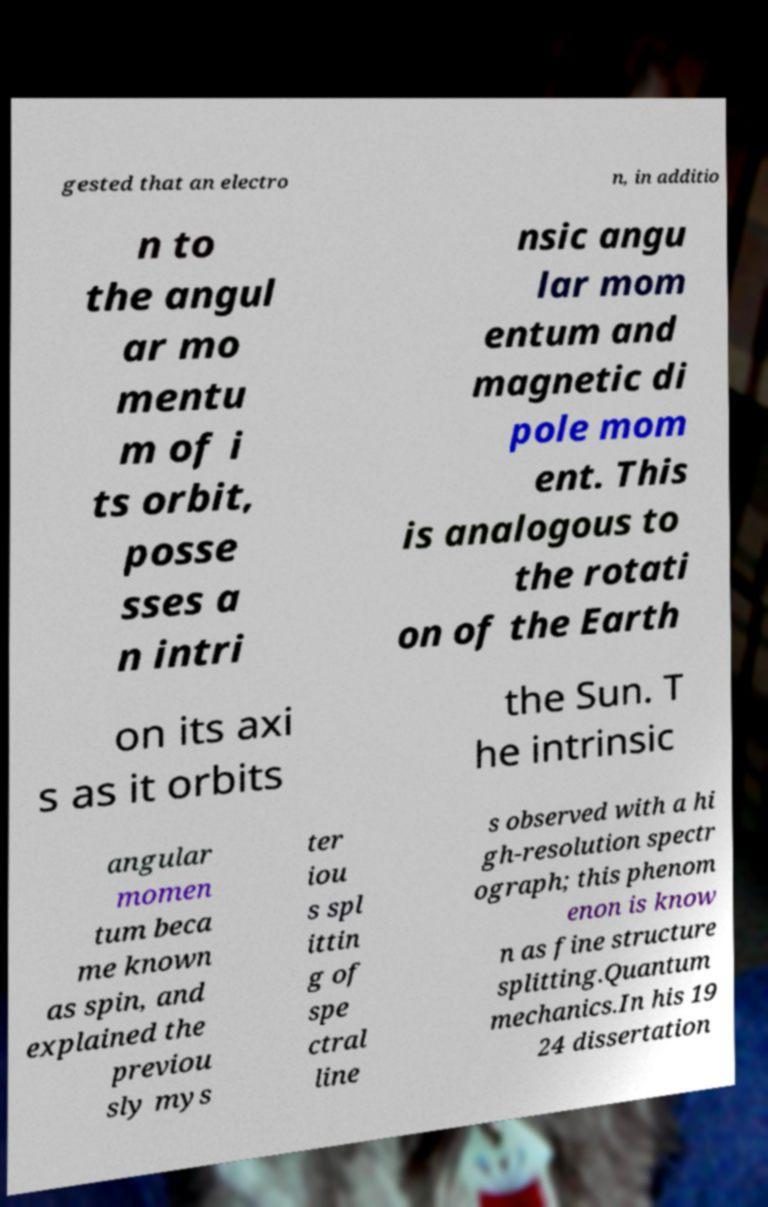Could you extract and type out the text from this image? gested that an electro n, in additio n to the angul ar mo mentu m of i ts orbit, posse sses a n intri nsic angu lar mom entum and magnetic di pole mom ent. This is analogous to the rotati on of the Earth on its axi s as it orbits the Sun. T he intrinsic angular momen tum beca me known as spin, and explained the previou sly mys ter iou s spl ittin g of spe ctral line s observed with a hi gh-resolution spectr ograph; this phenom enon is know n as fine structure splitting.Quantum mechanics.In his 19 24 dissertation 